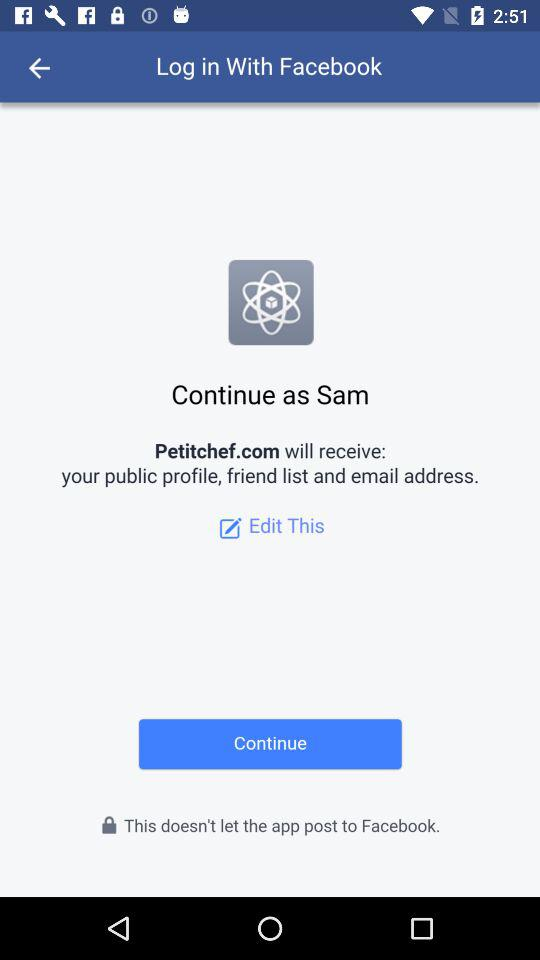What is the name of the user? The name of the user is Sam. 